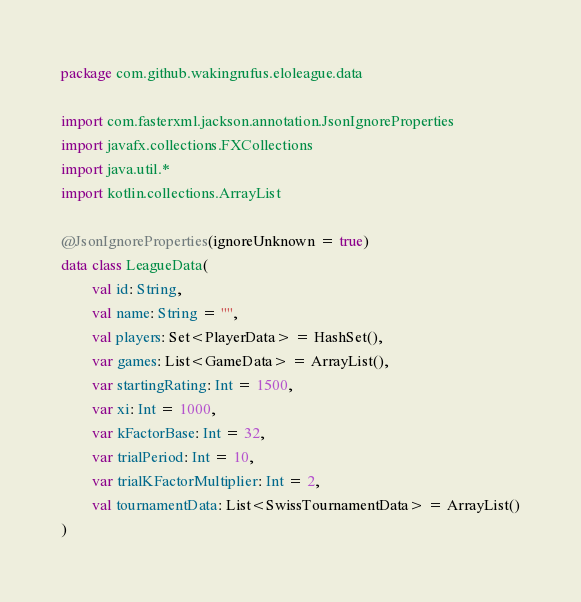Convert code to text. <code><loc_0><loc_0><loc_500><loc_500><_Kotlin_>package com.github.wakingrufus.eloleague.data

import com.fasterxml.jackson.annotation.JsonIgnoreProperties
import javafx.collections.FXCollections
import java.util.*
import kotlin.collections.ArrayList

@JsonIgnoreProperties(ignoreUnknown = true)
data class LeagueData(
        val id: String,
        val name: String = "",
        val players: Set<PlayerData> = HashSet(),
        var games: List<GameData> = ArrayList(),
        var startingRating: Int = 1500,
        var xi: Int = 1000,
        var kFactorBase: Int = 32,
        var trialPeriod: Int = 10,
        var trialKFactorMultiplier: Int = 2,
        val tournamentData: List<SwissTournamentData> = ArrayList()
)</code> 